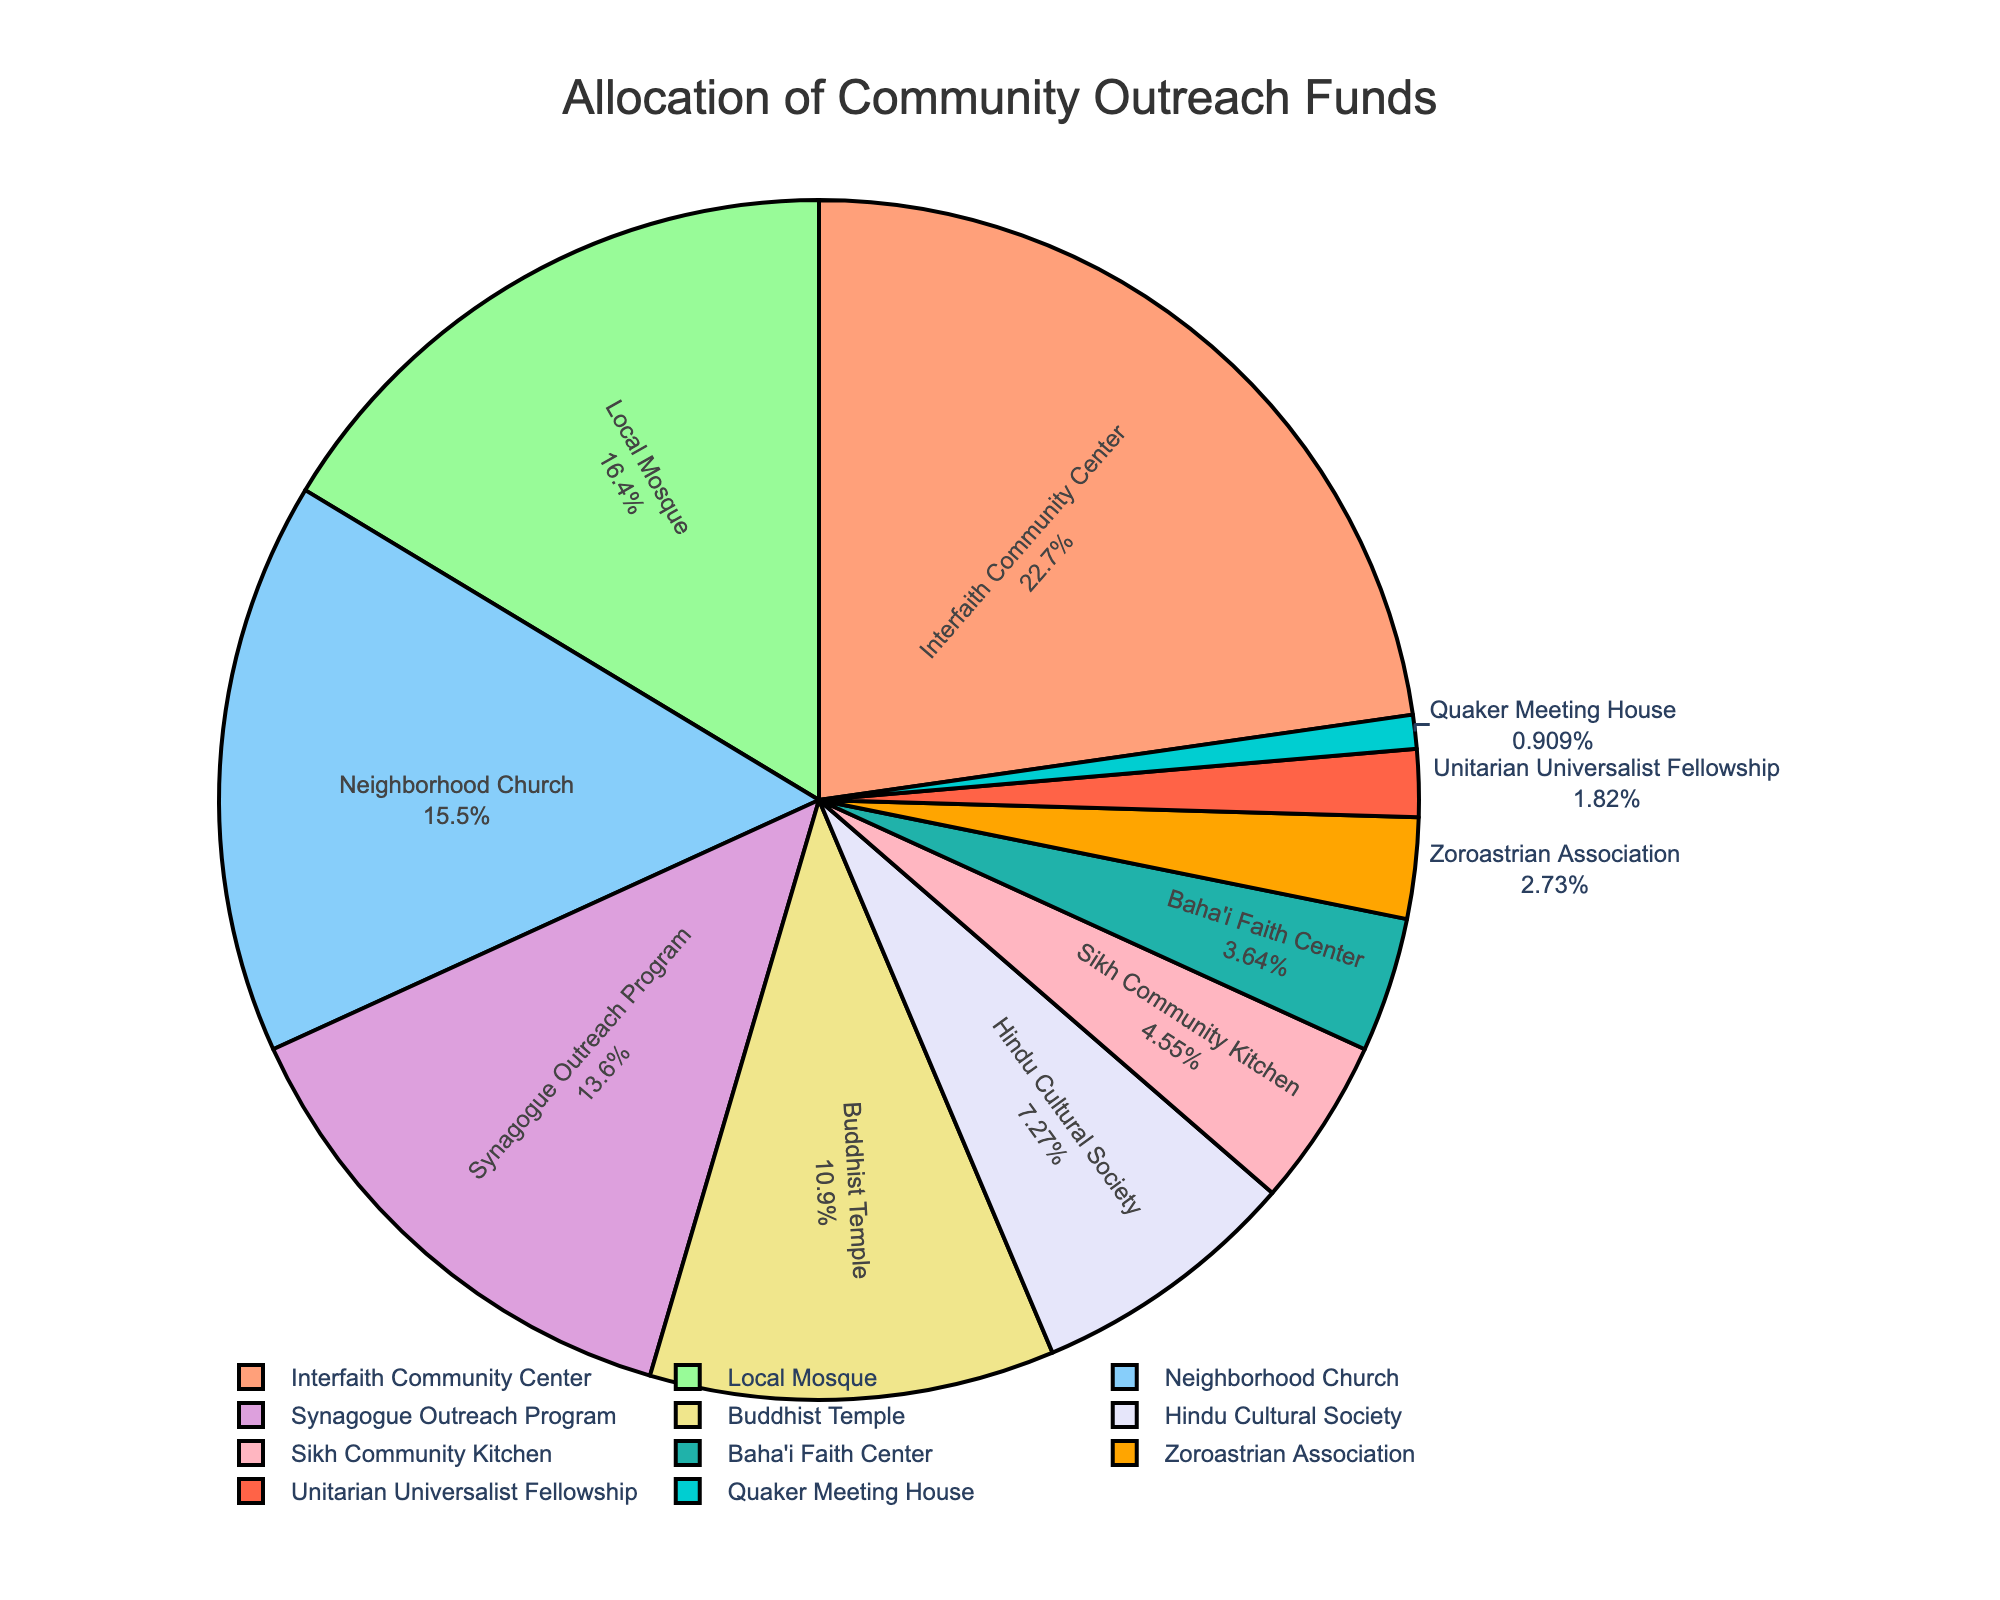What organization received the highest percentage of funding? The organization with the highest percentage is the Interfaith Community Center, which is visible at the top of the list in the pie chart.
Answer: Interfaith Community Center Which three organizations received the lowest percentages of funding? By looking at the smallest segments of the pie chart, the three organizations with the lowest funding percentages are the Quaker Meeting House, Unitarian Universalist Fellowship, and Zoroastrian Association.
Answer: Quaker Meeting House, Unitarian Universalist Fellowship, Zoroastrian Association How much more funding did the Local Mosque receive compared to the Sikh Community Kitchen? The Local Mosque received 18%, and the Sikh Community Kitchen received 5%. The difference is 18% - 5% = 13%.
Answer: 13% What is the combined percentage of funding for the Neighborhood Church, Synagogue Outreach Program, and Buddhist Temple? The percentages are 17% for the Neighborhood Church, 15% for the Synagogue Outreach Program, and 12% for the Buddhist Temple. Adding these together: 17% + 15% + 12% = 44%.
Answer: 44% Do any organizations have equal funding percentages? By examining the pie chart, we can see no two organizations have identical funding percentages.
Answer: No What percentage of funding was allocated to organizations related to Eastern religions (Buddhist Temple, Hindu Cultural Society, Sikh Community Kitchen)? The percentages are 12% for the Buddhist Temple, 8% for the Hindu Cultural Society, and 5% for the Sikh Community Kitchen. Adding these together: 12% + 8% + 5% = 25%.
Answer: 25% Which organization received exactly 15% funding? The labeling on the pie chart indicates that the Synagogue Outreach Program received exactly 15%.
Answer: Synagogue Outreach Program How does the funding for the Local Mosque compare to the funding for the Hindu Cultural Society? The Local Mosque received 18% of the funding, while the Hindu Cultural Society received 8%. The Local Mosque received a higher percentage of funding compared to the Hindu Cultural Society.
Answer: Local Mosque received more Which groups received less than 10% of the total funding? The organizations with less than 10% funding, as noted in the pie chart, are the Hindu Cultural Society, Sikh Community Kitchen, Baha'i Faith Center, Zoroastrian Association, Unitarian Universalist Fellowship, and Quaker Meeting House.
Answer: Hindu Cultural Society, Sikh Community Kitchen, Baha'i Faith Center, Zoroastrian Association, Unitarian Universalist Fellowship, Quaker Meeting House 